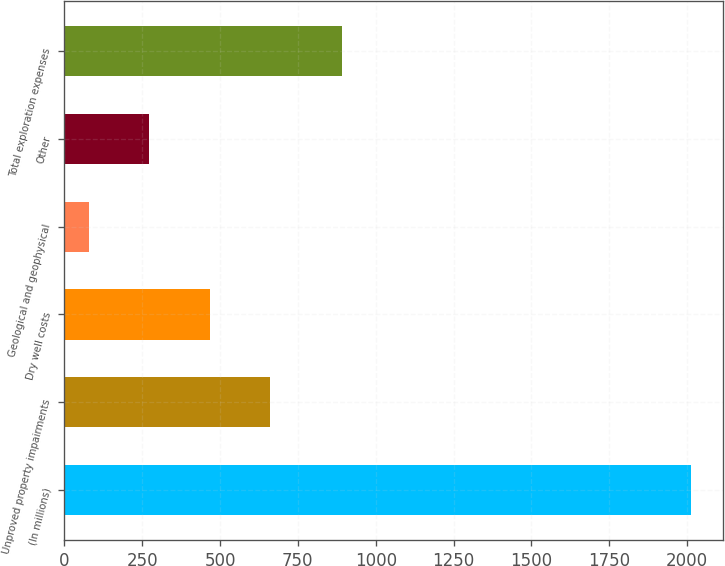Convert chart. <chart><loc_0><loc_0><loc_500><loc_500><bar_chart><fcel>(In millions)<fcel>Unproved property impairments<fcel>Dry well costs<fcel>Geological and geophysical<fcel>Other<fcel>Total exploration expenses<nl><fcel>2013<fcel>659.9<fcel>466.6<fcel>80<fcel>273.3<fcel>891<nl></chart> 